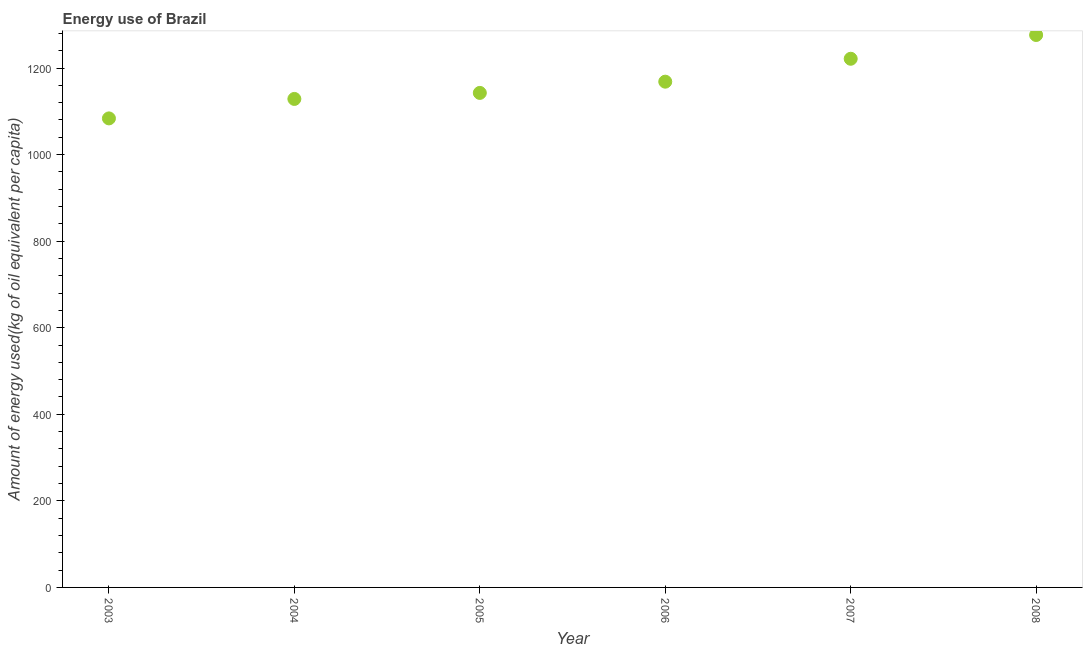What is the amount of energy used in 2006?
Your answer should be very brief. 1168.43. Across all years, what is the maximum amount of energy used?
Provide a short and direct response. 1276.27. Across all years, what is the minimum amount of energy used?
Provide a short and direct response. 1083.59. In which year was the amount of energy used minimum?
Your response must be concise. 2003. What is the sum of the amount of energy used?
Ensure brevity in your answer.  7020.67. What is the difference between the amount of energy used in 2004 and 2007?
Offer a terse response. -92.81. What is the average amount of energy used per year?
Offer a terse response. 1170.11. What is the median amount of energy used?
Give a very brief answer. 1155.45. What is the ratio of the amount of energy used in 2005 to that in 2008?
Ensure brevity in your answer.  0.9. What is the difference between the highest and the second highest amount of energy used?
Provide a succinct answer. 54.91. What is the difference between the highest and the lowest amount of energy used?
Your answer should be compact. 192.68. In how many years, is the amount of energy used greater than the average amount of energy used taken over all years?
Provide a short and direct response. 2. Does the amount of energy used monotonically increase over the years?
Give a very brief answer. Yes. Does the graph contain grids?
Give a very brief answer. No. What is the title of the graph?
Your response must be concise. Energy use of Brazil. What is the label or title of the Y-axis?
Provide a succinct answer. Amount of energy used(kg of oil equivalent per capita). What is the Amount of energy used(kg of oil equivalent per capita) in 2003?
Ensure brevity in your answer.  1083.59. What is the Amount of energy used(kg of oil equivalent per capita) in 2004?
Your answer should be very brief. 1128.55. What is the Amount of energy used(kg of oil equivalent per capita) in 2005?
Provide a succinct answer. 1142.47. What is the Amount of energy used(kg of oil equivalent per capita) in 2006?
Offer a very short reply. 1168.43. What is the Amount of energy used(kg of oil equivalent per capita) in 2007?
Your answer should be compact. 1221.36. What is the Amount of energy used(kg of oil equivalent per capita) in 2008?
Your answer should be very brief. 1276.27. What is the difference between the Amount of energy used(kg of oil equivalent per capita) in 2003 and 2004?
Make the answer very short. -44.96. What is the difference between the Amount of energy used(kg of oil equivalent per capita) in 2003 and 2005?
Provide a succinct answer. -58.88. What is the difference between the Amount of energy used(kg of oil equivalent per capita) in 2003 and 2006?
Make the answer very short. -84.84. What is the difference between the Amount of energy used(kg of oil equivalent per capita) in 2003 and 2007?
Offer a terse response. -137.77. What is the difference between the Amount of energy used(kg of oil equivalent per capita) in 2003 and 2008?
Make the answer very short. -192.68. What is the difference between the Amount of energy used(kg of oil equivalent per capita) in 2004 and 2005?
Provide a succinct answer. -13.92. What is the difference between the Amount of energy used(kg of oil equivalent per capita) in 2004 and 2006?
Keep it short and to the point. -39.88. What is the difference between the Amount of energy used(kg of oil equivalent per capita) in 2004 and 2007?
Provide a succinct answer. -92.81. What is the difference between the Amount of energy used(kg of oil equivalent per capita) in 2004 and 2008?
Your answer should be compact. -147.72. What is the difference between the Amount of energy used(kg of oil equivalent per capita) in 2005 and 2006?
Your response must be concise. -25.96. What is the difference between the Amount of energy used(kg of oil equivalent per capita) in 2005 and 2007?
Offer a very short reply. -78.89. What is the difference between the Amount of energy used(kg of oil equivalent per capita) in 2005 and 2008?
Ensure brevity in your answer.  -133.8. What is the difference between the Amount of energy used(kg of oil equivalent per capita) in 2006 and 2007?
Your answer should be very brief. -52.93. What is the difference between the Amount of energy used(kg of oil equivalent per capita) in 2006 and 2008?
Give a very brief answer. -107.84. What is the difference between the Amount of energy used(kg of oil equivalent per capita) in 2007 and 2008?
Ensure brevity in your answer.  -54.91. What is the ratio of the Amount of energy used(kg of oil equivalent per capita) in 2003 to that in 2005?
Offer a terse response. 0.95. What is the ratio of the Amount of energy used(kg of oil equivalent per capita) in 2003 to that in 2006?
Ensure brevity in your answer.  0.93. What is the ratio of the Amount of energy used(kg of oil equivalent per capita) in 2003 to that in 2007?
Keep it short and to the point. 0.89. What is the ratio of the Amount of energy used(kg of oil equivalent per capita) in 2003 to that in 2008?
Give a very brief answer. 0.85. What is the ratio of the Amount of energy used(kg of oil equivalent per capita) in 2004 to that in 2005?
Offer a very short reply. 0.99. What is the ratio of the Amount of energy used(kg of oil equivalent per capita) in 2004 to that in 2006?
Your answer should be very brief. 0.97. What is the ratio of the Amount of energy used(kg of oil equivalent per capita) in 2004 to that in 2007?
Make the answer very short. 0.92. What is the ratio of the Amount of energy used(kg of oil equivalent per capita) in 2004 to that in 2008?
Offer a terse response. 0.88. What is the ratio of the Amount of energy used(kg of oil equivalent per capita) in 2005 to that in 2007?
Give a very brief answer. 0.94. What is the ratio of the Amount of energy used(kg of oil equivalent per capita) in 2005 to that in 2008?
Your answer should be compact. 0.9. What is the ratio of the Amount of energy used(kg of oil equivalent per capita) in 2006 to that in 2007?
Your answer should be very brief. 0.96. What is the ratio of the Amount of energy used(kg of oil equivalent per capita) in 2006 to that in 2008?
Your answer should be compact. 0.92. 